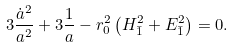Convert formula to latex. <formula><loc_0><loc_0><loc_500><loc_500>3 \frac { \dot { a } ^ { 2 } } { a ^ { 2 } } + 3 \frac { 1 } { a } - r _ { 0 } ^ { 2 } \left ( H _ { \bar { 1 } } ^ { 2 } + E _ { \bar { 1 } } ^ { 2 } \right ) = 0 .</formula> 